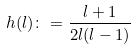<formula> <loc_0><loc_0><loc_500><loc_500>h ( l ) \colon = \frac { l + 1 } { 2 l ( l - 1 ) }</formula> 